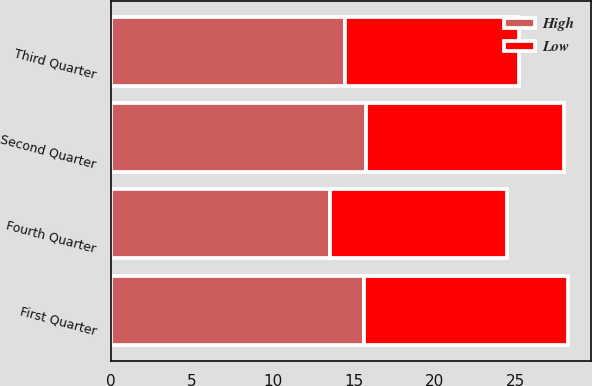Convert chart. <chart><loc_0><loc_0><loc_500><loc_500><stacked_bar_chart><ecel><fcel>First Quarter<fcel>Second Quarter<fcel>Third Quarter<fcel>Fourth Quarter<nl><fcel>High<fcel>15.62<fcel>15.74<fcel>14.45<fcel>13.55<nl><fcel>Low<fcel>12.62<fcel>12.24<fcel>10.74<fcel>10.9<nl></chart> 